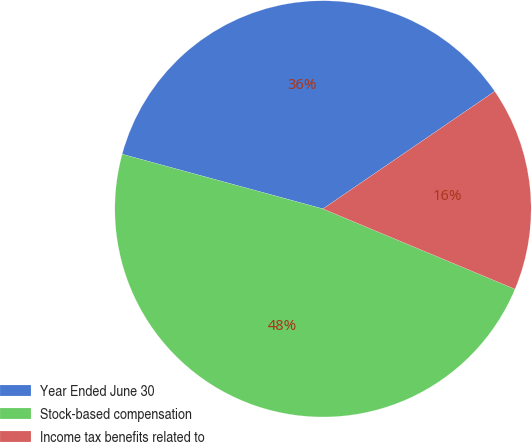Convert chart. <chart><loc_0><loc_0><loc_500><loc_500><pie_chart><fcel>Year Ended June 30<fcel>Stock-based compensation<fcel>Income tax benefits related to<nl><fcel>36.22%<fcel>47.93%<fcel>15.85%<nl></chart> 